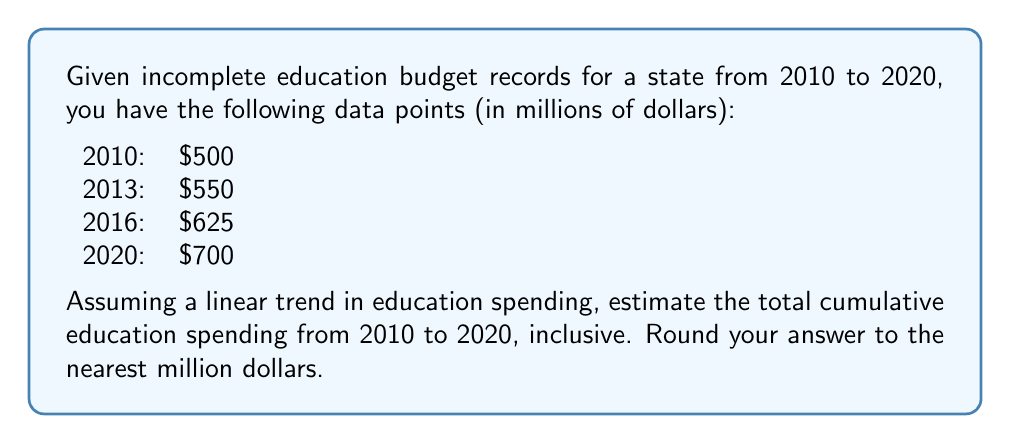What is the answer to this math problem? To solve this problem, we'll follow these steps:

1) First, we need to determine the linear equation for education spending over time. We can use the points (0, 500) and (10, 700) to find the slope and y-intercept.

2) The slope (m) is:
   $$m = \frac{700 - 500}{10 - 0} = 20$$

3) The y-intercept (b) is 500. So our equation is:
   $$y = 20x + 500$$
   where x is the number of years since 2010 and y is the spending in millions.

4) Now we need to calculate the spending for each year from 2010 to 2020:

   2010 (x=0):  $y = 20(0) + 500 = 500$
   2011 (x=1):  $y = 20(1) + 500 = 520$
   2012 (x=2):  $y = 20(2) + 500 = 540$
   2013 (x=3):  $y = 20(3) + 500 = 560$
   2014 (x=4):  $y = 20(4) + 500 = 580$
   2015 (x=5):  $y = 20(5) + 500 = 600$
   2016 (x=6):  $y = 20(6) + 500 = 620$
   2017 (x=7):  $y = 20(7) + 500 = 640$
   2018 (x=8):  $y = 20(8) + 500 = 660$
   2019 (x=9):  $y = 20(9) + 500 = 680$
   2020 (x=10): $y = 20(10) + 500 = 700$

5) To get the total cumulative spending, we sum all these values:

   $$500 + 520 + 540 + 560 + 580 + 600 + 620 + 640 + 660 + 680 + 700 = 6600$$

Therefore, the total cumulative education spending from 2010 to 2020 is $6,600 million.
Answer: $6,600 million 